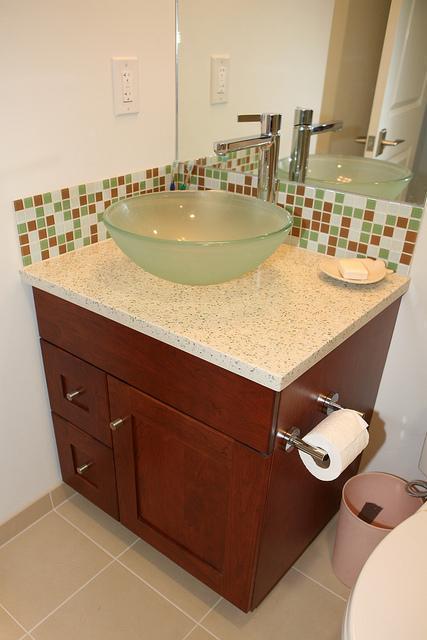How many colors are in the tile?
Give a very brief answer. 3. 